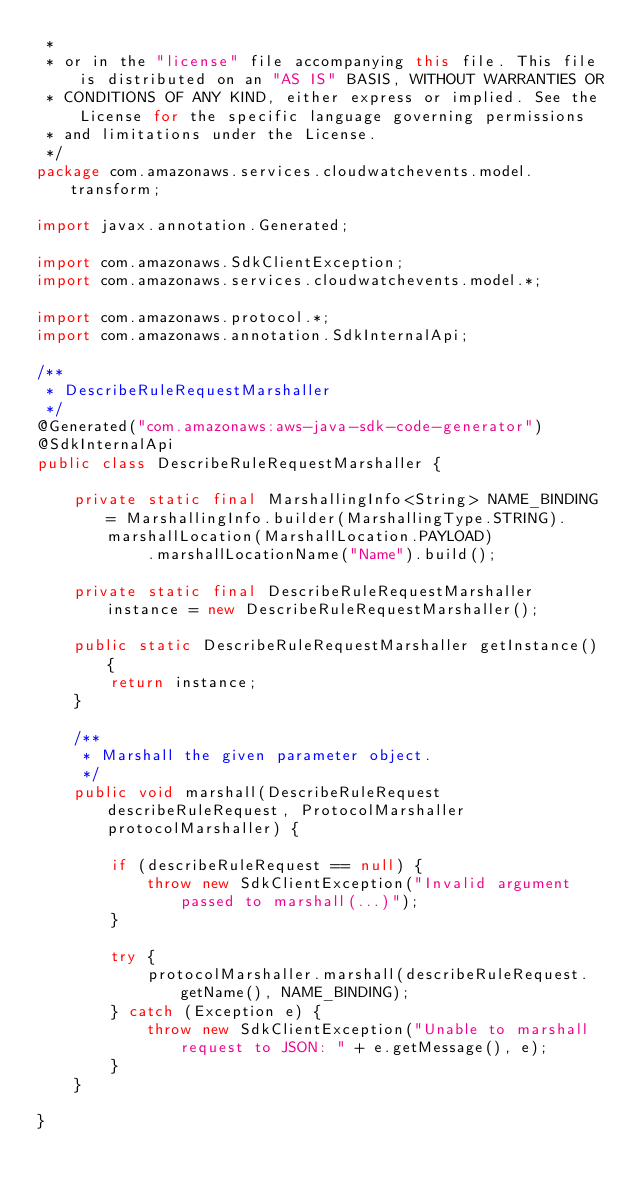<code> <loc_0><loc_0><loc_500><loc_500><_Java_> * 
 * or in the "license" file accompanying this file. This file is distributed on an "AS IS" BASIS, WITHOUT WARRANTIES OR
 * CONDITIONS OF ANY KIND, either express or implied. See the License for the specific language governing permissions
 * and limitations under the License.
 */
package com.amazonaws.services.cloudwatchevents.model.transform;

import javax.annotation.Generated;

import com.amazonaws.SdkClientException;
import com.amazonaws.services.cloudwatchevents.model.*;

import com.amazonaws.protocol.*;
import com.amazonaws.annotation.SdkInternalApi;

/**
 * DescribeRuleRequestMarshaller
 */
@Generated("com.amazonaws:aws-java-sdk-code-generator")
@SdkInternalApi
public class DescribeRuleRequestMarshaller {

    private static final MarshallingInfo<String> NAME_BINDING = MarshallingInfo.builder(MarshallingType.STRING).marshallLocation(MarshallLocation.PAYLOAD)
            .marshallLocationName("Name").build();

    private static final DescribeRuleRequestMarshaller instance = new DescribeRuleRequestMarshaller();

    public static DescribeRuleRequestMarshaller getInstance() {
        return instance;
    }

    /**
     * Marshall the given parameter object.
     */
    public void marshall(DescribeRuleRequest describeRuleRequest, ProtocolMarshaller protocolMarshaller) {

        if (describeRuleRequest == null) {
            throw new SdkClientException("Invalid argument passed to marshall(...)");
        }

        try {
            protocolMarshaller.marshall(describeRuleRequest.getName(), NAME_BINDING);
        } catch (Exception e) {
            throw new SdkClientException("Unable to marshall request to JSON: " + e.getMessage(), e);
        }
    }

}
</code> 